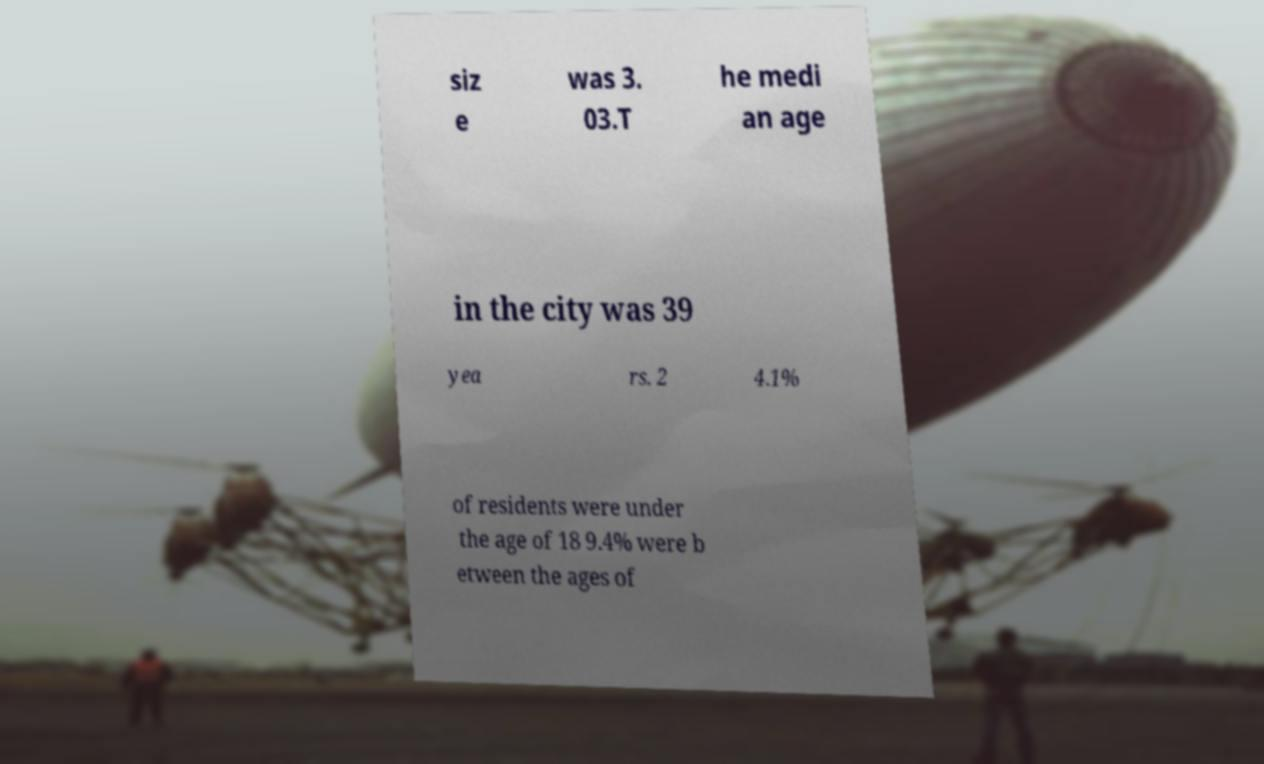Please read and relay the text visible in this image. What does it say? siz e was 3. 03.T he medi an age in the city was 39 yea rs. 2 4.1% of residents were under the age of 18 9.4% were b etween the ages of 